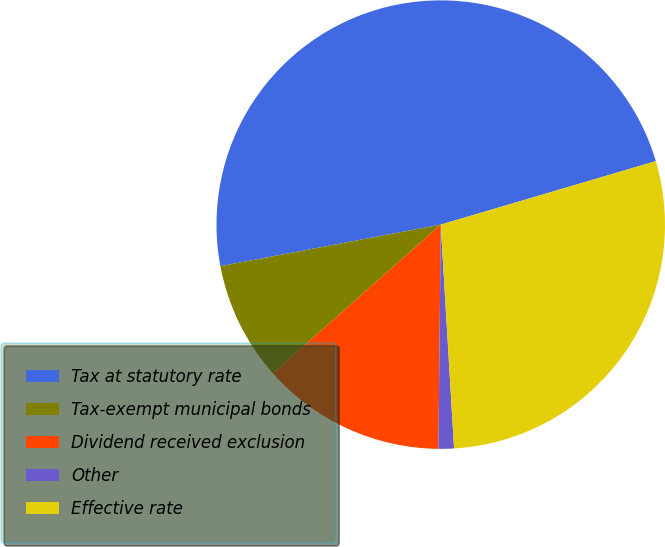Convert chart to OTSL. <chart><loc_0><loc_0><loc_500><loc_500><pie_chart><fcel>Tax at statutory rate<fcel>Tax-exempt municipal bonds<fcel>Dividend received exclusion<fcel>Other<fcel>Effective rate<nl><fcel>48.4%<fcel>8.57%<fcel>13.3%<fcel>1.11%<fcel>28.62%<nl></chart> 